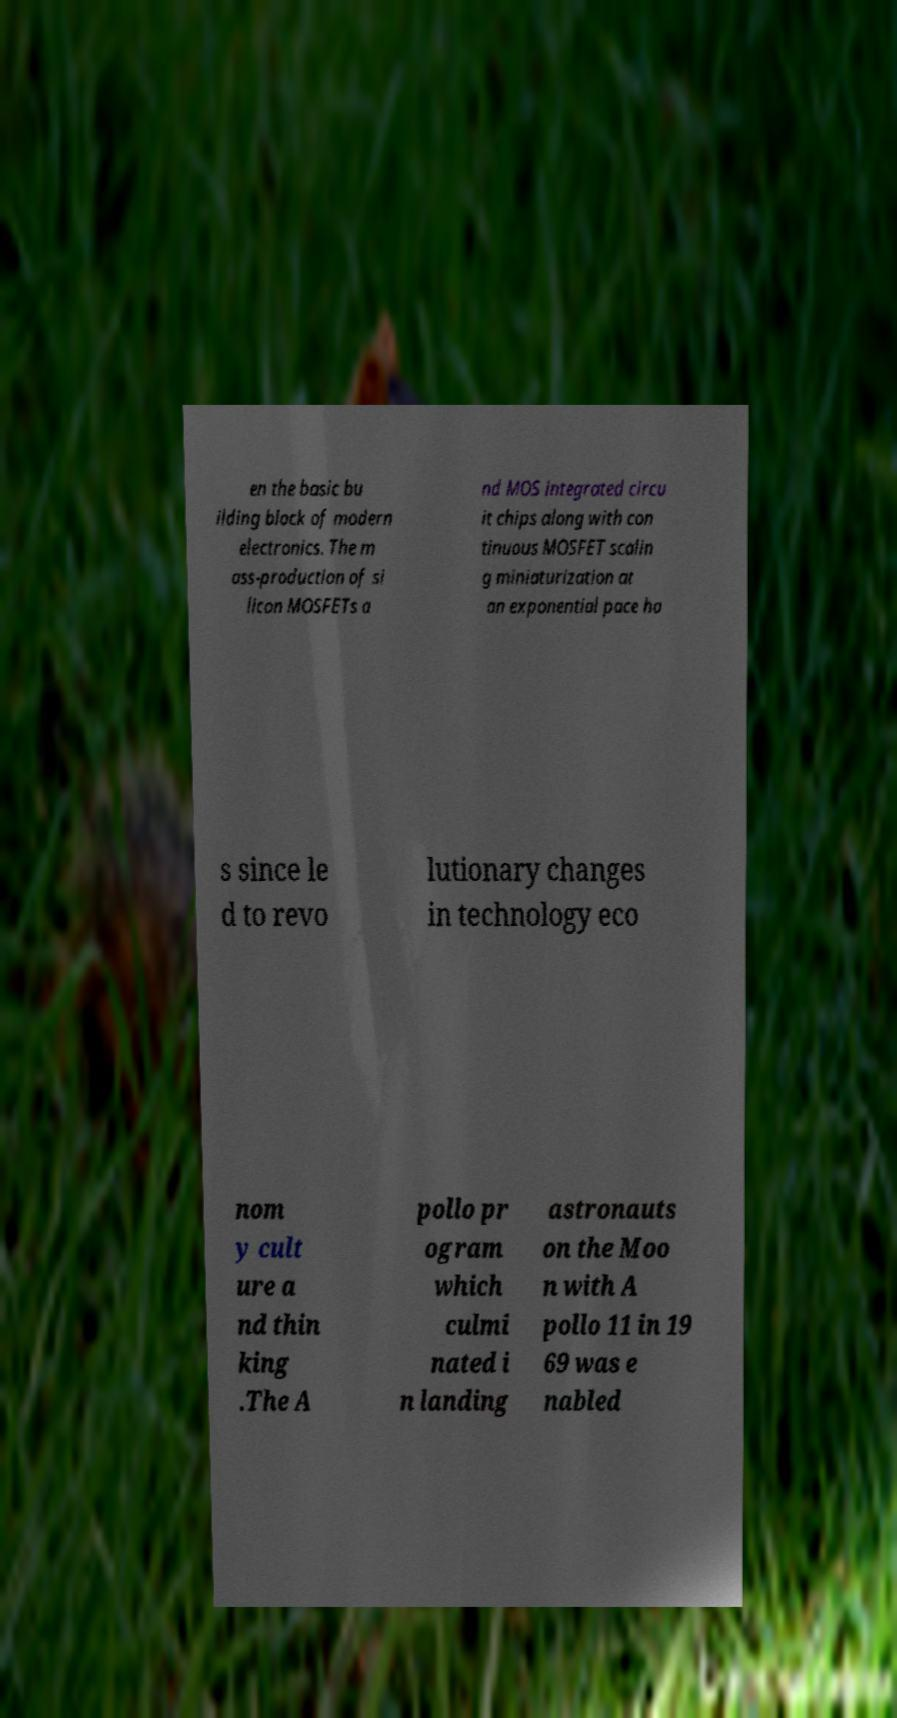Can you accurately transcribe the text from the provided image for me? en the basic bu ilding block of modern electronics. The m ass-production of si licon MOSFETs a nd MOS integrated circu it chips along with con tinuous MOSFET scalin g miniaturization at an exponential pace ha s since le d to revo lutionary changes in technology eco nom y cult ure a nd thin king .The A pollo pr ogram which culmi nated i n landing astronauts on the Moo n with A pollo 11 in 19 69 was e nabled 